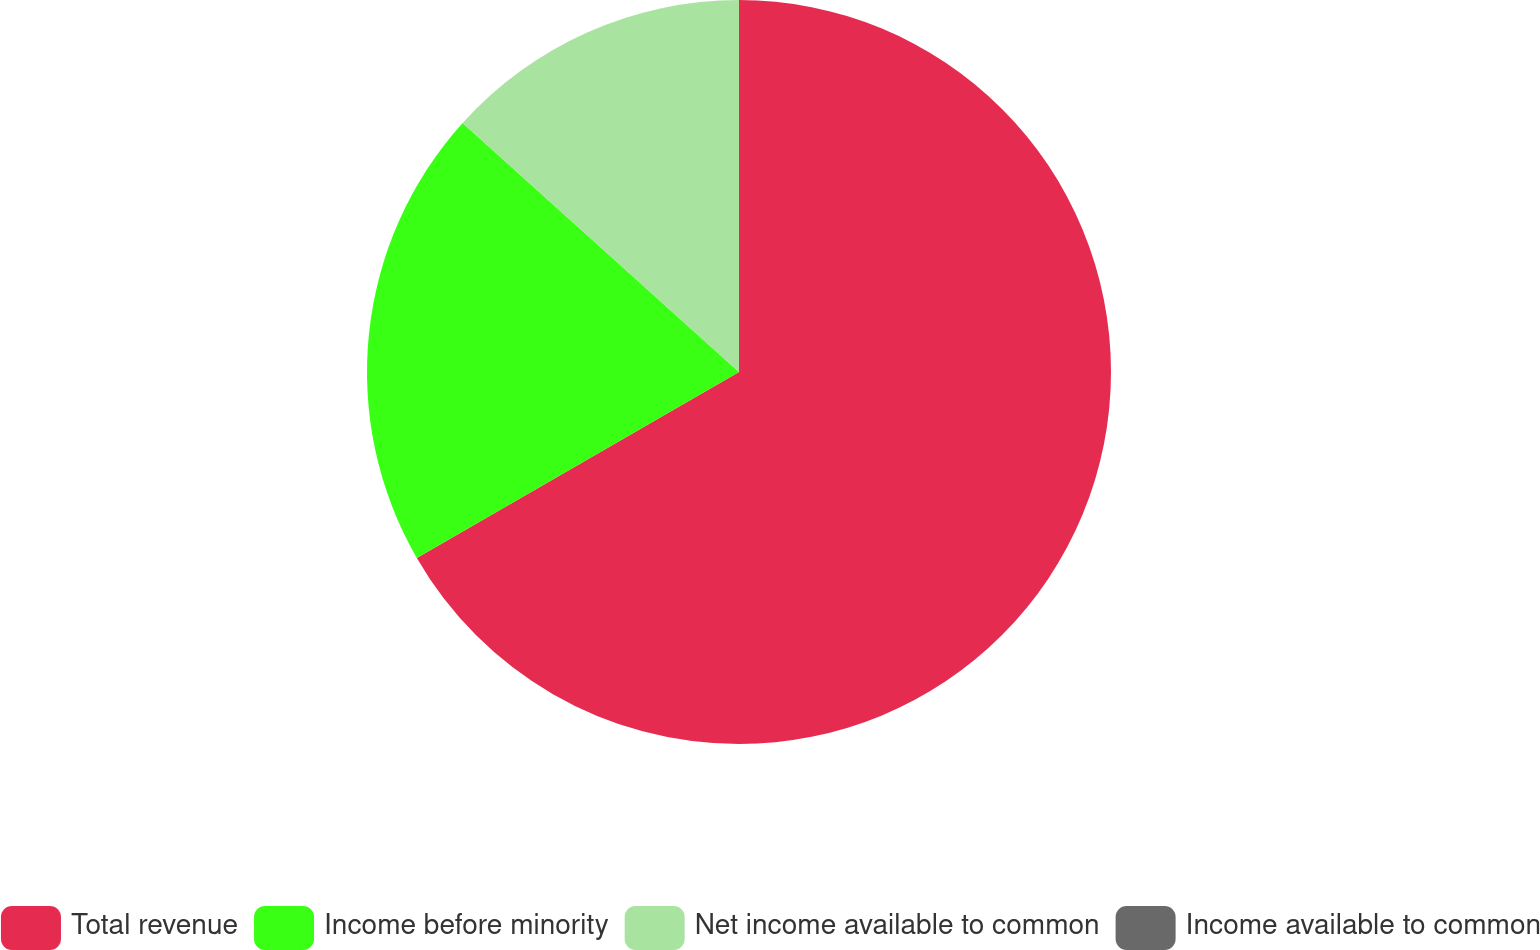Convert chart. <chart><loc_0><loc_0><loc_500><loc_500><pie_chart><fcel>Total revenue<fcel>Income before minority<fcel>Net income available to common<fcel>Income available to common<nl><fcel>66.67%<fcel>20.0%<fcel>13.33%<fcel>0.0%<nl></chart> 